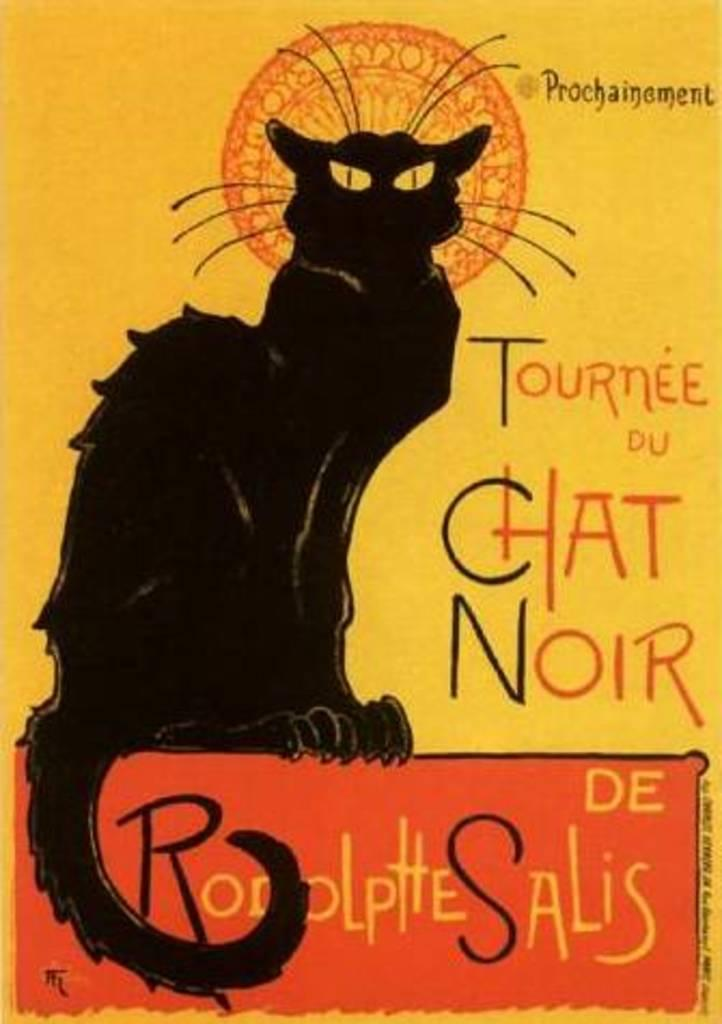What is the main subject of the poster in the image? The poster features a black cat. What else can be seen on the poster besides the cat? There is text on the poster. How many trucks are mentioned in the text on the poster? There is no mention of trucks in the text on the poster, as the poster features a black cat and text about the cat. 